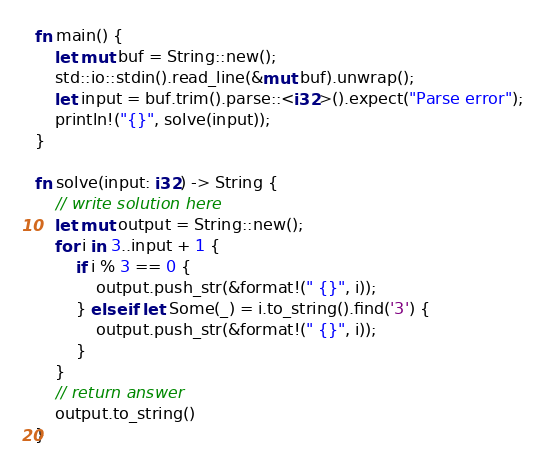<code> <loc_0><loc_0><loc_500><loc_500><_Rust_>fn main() {
    let mut buf = String::new();
    std::io::stdin().read_line(&mut buf).unwrap();
    let input = buf.trim().parse::<i32>().expect("Parse error");
    println!("{}", solve(input));
}

fn solve(input: i32) -> String {
    // write solution here
    let mut output = String::new();
    for i in 3..input + 1 {
        if i % 3 == 0 {
            output.push_str(&format!(" {}", i));
        } else if let Some(_) = i.to_string().find('3') {
            output.push_str(&format!(" {}", i));
        }
    }
    // return answer
    output.to_string()
}

</code> 